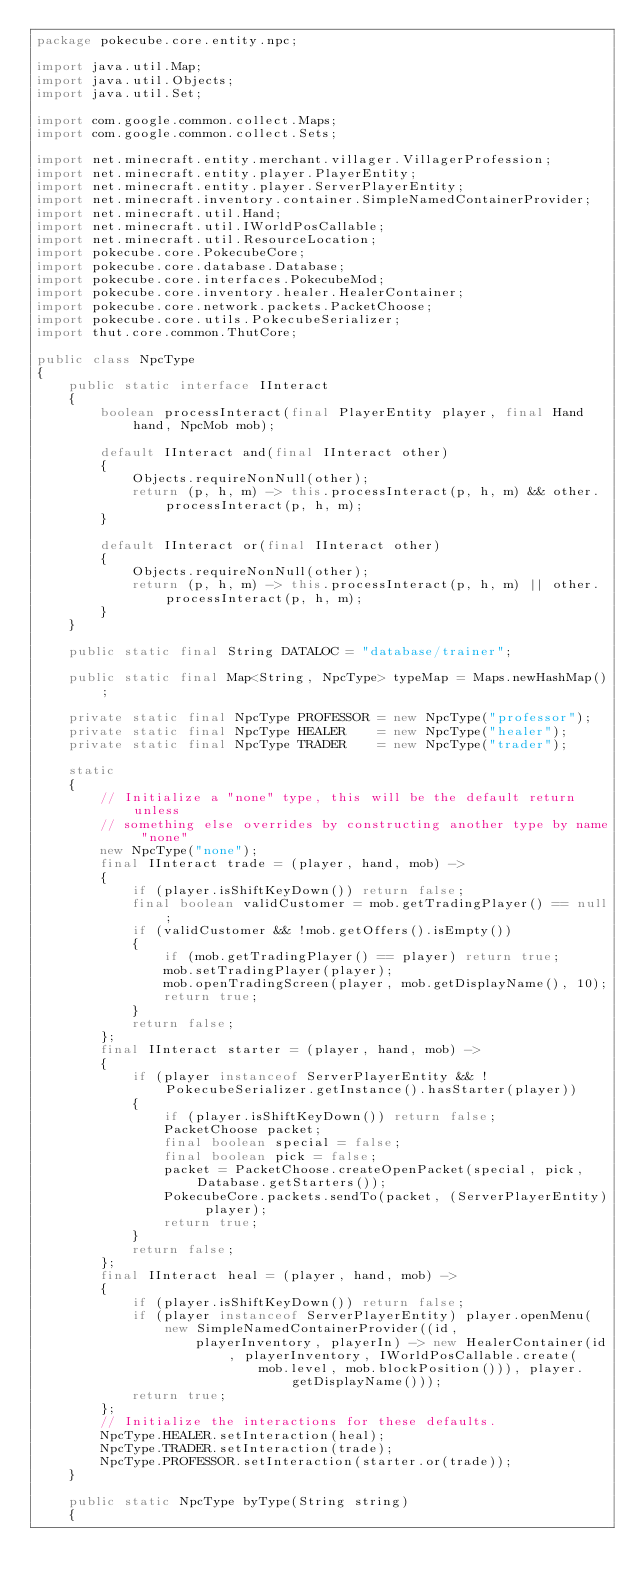Convert code to text. <code><loc_0><loc_0><loc_500><loc_500><_Java_>package pokecube.core.entity.npc;

import java.util.Map;
import java.util.Objects;
import java.util.Set;

import com.google.common.collect.Maps;
import com.google.common.collect.Sets;

import net.minecraft.entity.merchant.villager.VillagerProfession;
import net.minecraft.entity.player.PlayerEntity;
import net.minecraft.entity.player.ServerPlayerEntity;
import net.minecraft.inventory.container.SimpleNamedContainerProvider;
import net.minecraft.util.Hand;
import net.minecraft.util.IWorldPosCallable;
import net.minecraft.util.ResourceLocation;
import pokecube.core.PokecubeCore;
import pokecube.core.database.Database;
import pokecube.core.interfaces.PokecubeMod;
import pokecube.core.inventory.healer.HealerContainer;
import pokecube.core.network.packets.PacketChoose;
import pokecube.core.utils.PokecubeSerializer;
import thut.core.common.ThutCore;

public class NpcType
{
    public static interface IInteract
    {
        boolean processInteract(final PlayerEntity player, final Hand hand, NpcMob mob);

        default IInteract and(final IInteract other)
        {
            Objects.requireNonNull(other);
            return (p, h, m) -> this.processInteract(p, h, m) && other.processInteract(p, h, m);
        }

        default IInteract or(final IInteract other)
        {
            Objects.requireNonNull(other);
            return (p, h, m) -> this.processInteract(p, h, m) || other.processInteract(p, h, m);
        }
    }

    public static final String DATALOC = "database/trainer";

    public static final Map<String, NpcType> typeMap = Maps.newHashMap();

    private static final NpcType PROFESSOR = new NpcType("professor");
    private static final NpcType HEALER    = new NpcType("healer");
    private static final NpcType TRADER    = new NpcType("trader");

    static
    {
        // Initialize a "none" type, this will be the default return unless
        // something else overrides by constructing another type by name "none"
        new NpcType("none");
        final IInteract trade = (player, hand, mob) ->
        {
            if (player.isShiftKeyDown()) return false;
            final boolean validCustomer = mob.getTradingPlayer() == null;
            if (validCustomer && !mob.getOffers().isEmpty())
            {
                if (mob.getTradingPlayer() == player) return true;
                mob.setTradingPlayer(player);
                mob.openTradingScreen(player, mob.getDisplayName(), 10);
                return true;
            }
            return false;
        };
        final IInteract starter = (player, hand, mob) ->
        {
            if (player instanceof ServerPlayerEntity && !PokecubeSerializer.getInstance().hasStarter(player))
            {
                if (player.isShiftKeyDown()) return false;
                PacketChoose packet;
                final boolean special = false;
                final boolean pick = false;
                packet = PacketChoose.createOpenPacket(special, pick, Database.getStarters());
                PokecubeCore.packets.sendTo(packet, (ServerPlayerEntity) player);
                return true;
            }
            return false;
        };
        final IInteract heal = (player, hand, mob) ->
        {
            if (player.isShiftKeyDown()) return false;
            if (player instanceof ServerPlayerEntity) player.openMenu(new SimpleNamedContainerProvider((id,
                    playerInventory, playerIn) -> new HealerContainer(id, playerInventory, IWorldPosCallable.create(
                            mob.level, mob.blockPosition())), player.getDisplayName()));
            return true;
        };
        // Initialize the interactions for these defaults.
        NpcType.HEALER.setInteraction(heal);
        NpcType.TRADER.setInteraction(trade);
        NpcType.PROFESSOR.setInteraction(starter.or(trade));
    }

    public static NpcType byType(String string)
    {</code> 